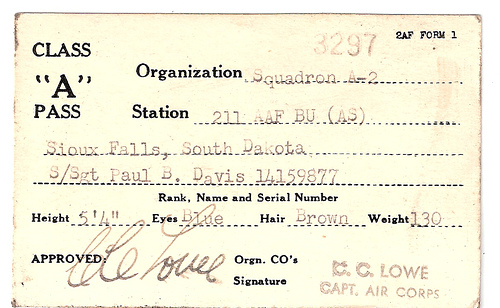<image>
Is the name next to the class? No. The name is not positioned next to the class. They are located in different areas of the scene. 